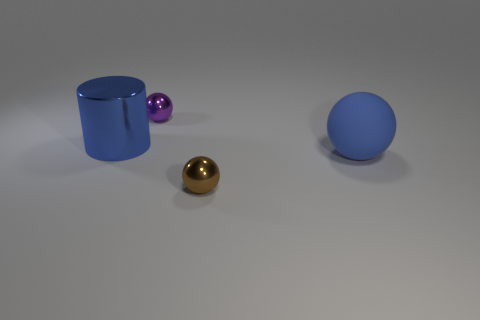What objects can you identify in the scene, and what are their colors? In the scene, there are three distinct objects: a cylindrical blue container on the left, a medium-sized golden metallic ball in the front, and a small purple shiny sphere to the right along with a larger blue sphere further behind. The surface they rest upon seems to be a matte gray plane. 